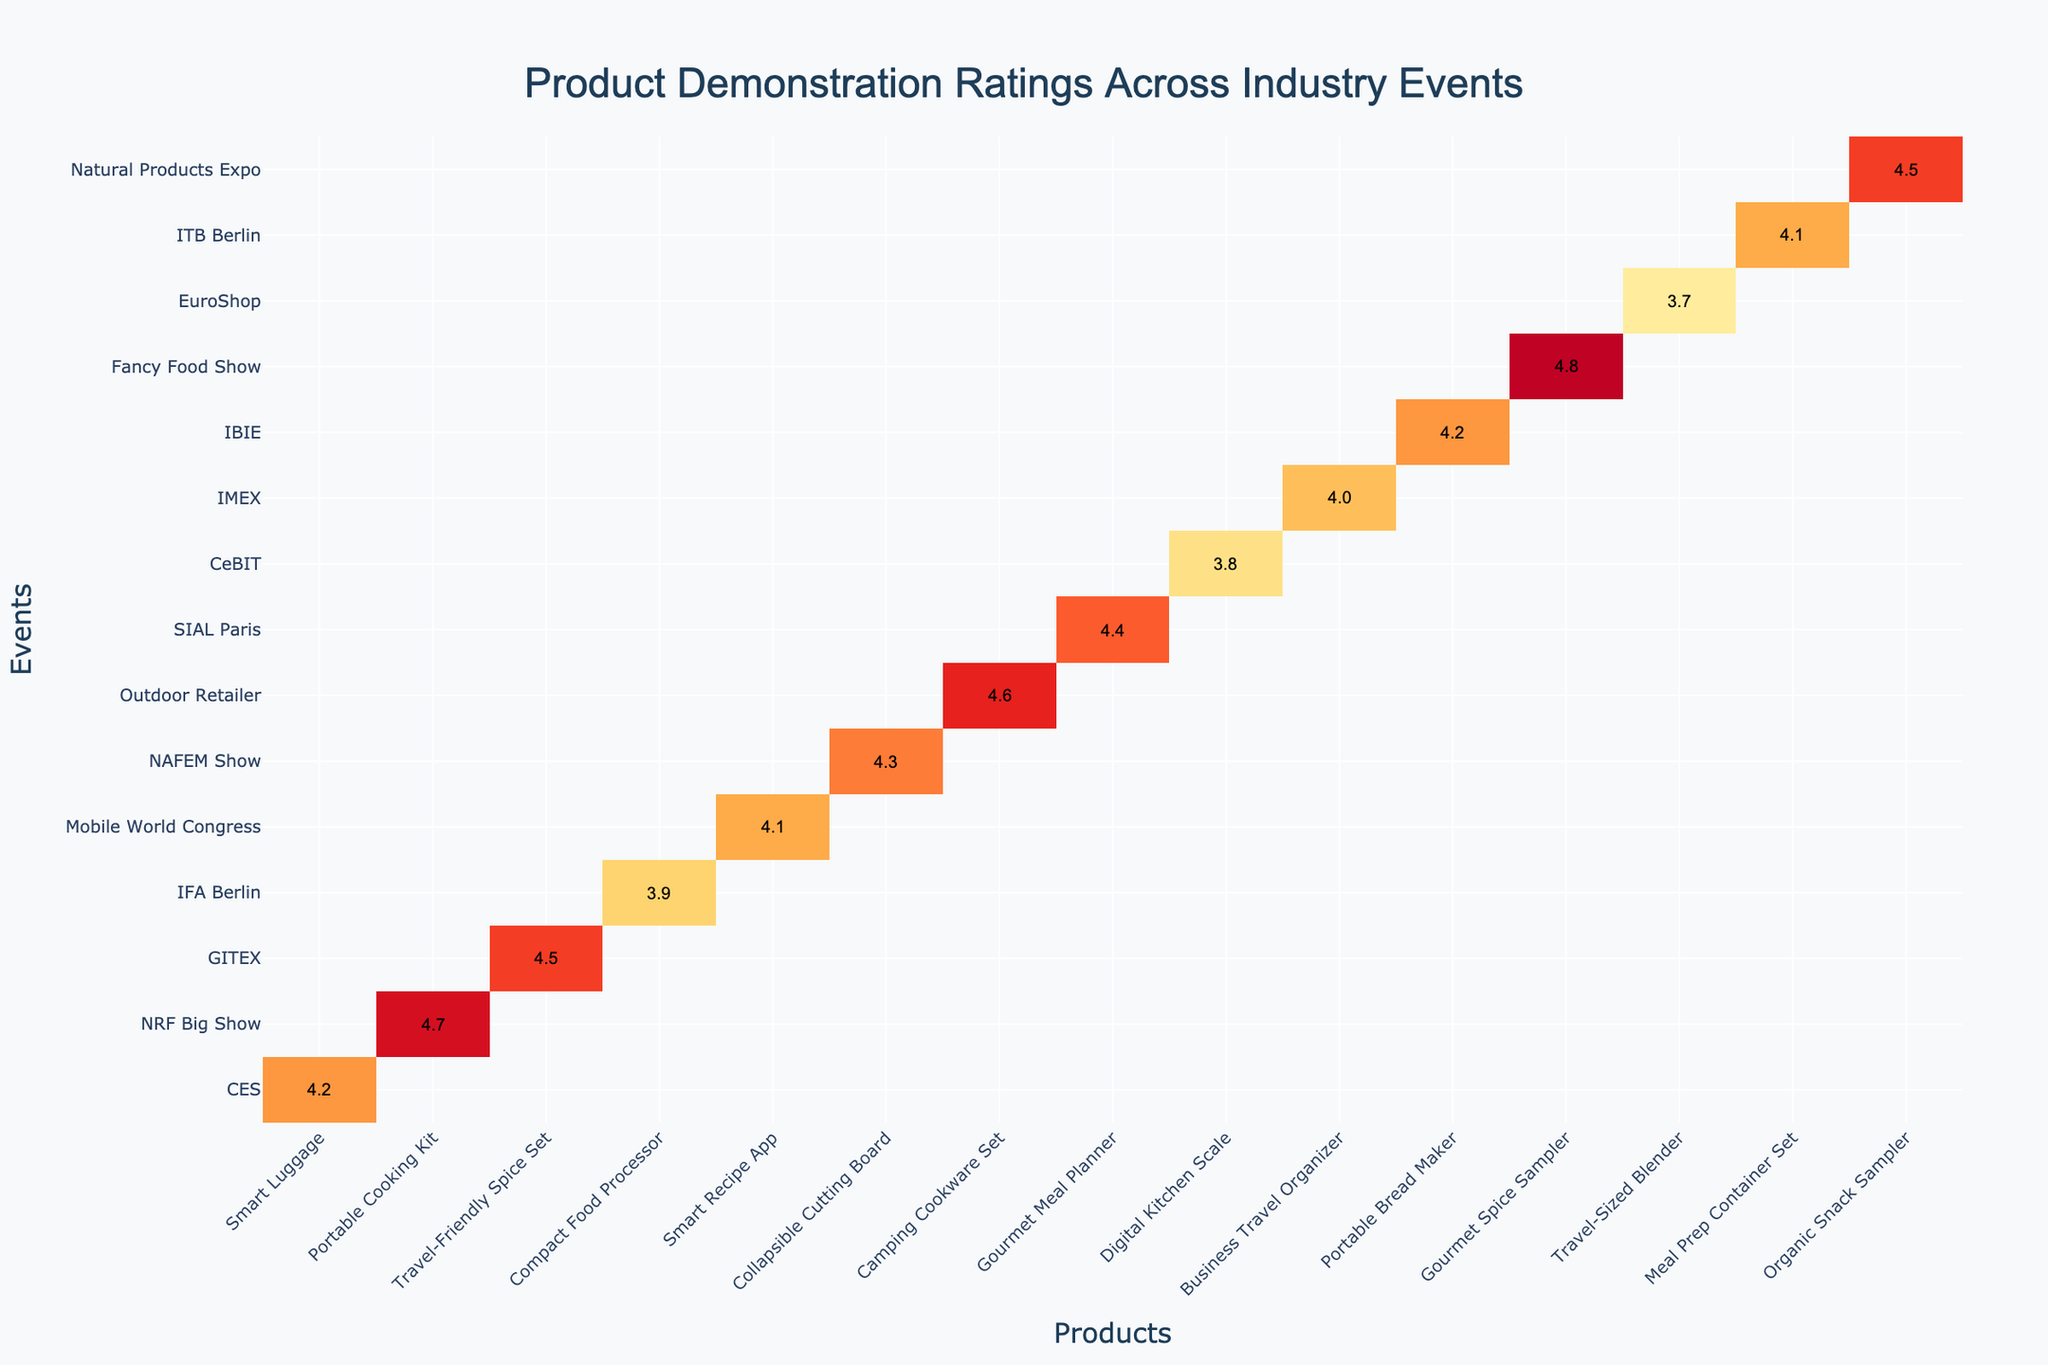What is the highest rating achieved at any event? The ratings for each event show that the highest value is 4.8, from the Gourmet Spice Sampler at the Fancy Food Show.
Answer: 4.8 Which event had the lowest rating for a product demonstration? Looking through the table, the event with the lowest rating is the EuroShop, with a rating of 3.7 for the Travel-Sized Blender.
Answer: EuroShop What is the average rating of all products demonstrated at the NAFEM Show? The NAFEM Show only has one product with a rating of 4.3, so the average rating is 4.3 itself.
Answer: 4.3 How many products received a rating of 4.5 or higher? From the data, the products that received a rating of 4.5 or higher are the Portable Cooking Kit, Travel-Friendly Spice Set, Camping Cookware Set, Gourmet Meal Planner, Gourmet Spice Sampler, and Organic Snack Sampler—totally 6 products.
Answer: 6 Is the rating for the Smart Recipe App higher than the rating for the Compact Food Processor? The Smart Recipe App has a rating of 4.1, while the Compact Food Processor has a lower rating of 3.9, making the statement true.
Answer: Yes What is the difference in rating between the highest-rated product and the lowest-rated product? The highest rating is 4.8 and the lowest is 3.7. The difference is 4.8 - 3.7 = 1.1.
Answer: 1.1 Which event showcased the most products with ratings above 4.0? By reviewing the table, it can be determined that the event with the most products rated above 4.0 is the Fancy Food Show, showcasing one product rated 4.8. However, a closer look is needed across all events. The Outdoor Retailer and NRF Big Show show multiple products just above 4.0 (two products each), which results in a tie for most.
Answer: NRF Big Show and Outdoor Retailer In which event did the Portable Cooking Kit receive its rating? The Portable Cooking Kit was demonstrated during the NRF Big Show, where it received a rating of 4.7.
Answer: NRF Big Show What is the combined rating of all products demonstrated at CES and GITEX? CES has a rating of 4.2 for Smart Luggage, and GITEX has a rating of 4.5 for the Travel-Friendly Spice Set. The combined rating is 4.2 + 4.5 = 8.7.
Answer: 8.7 Is there any event that had no product rated below 4.0? Among the events listed, both the NRF Big Show and the Fancy Food Show did not have any products rated below 4.0, confirming the statement to be true.
Answer: Yes 